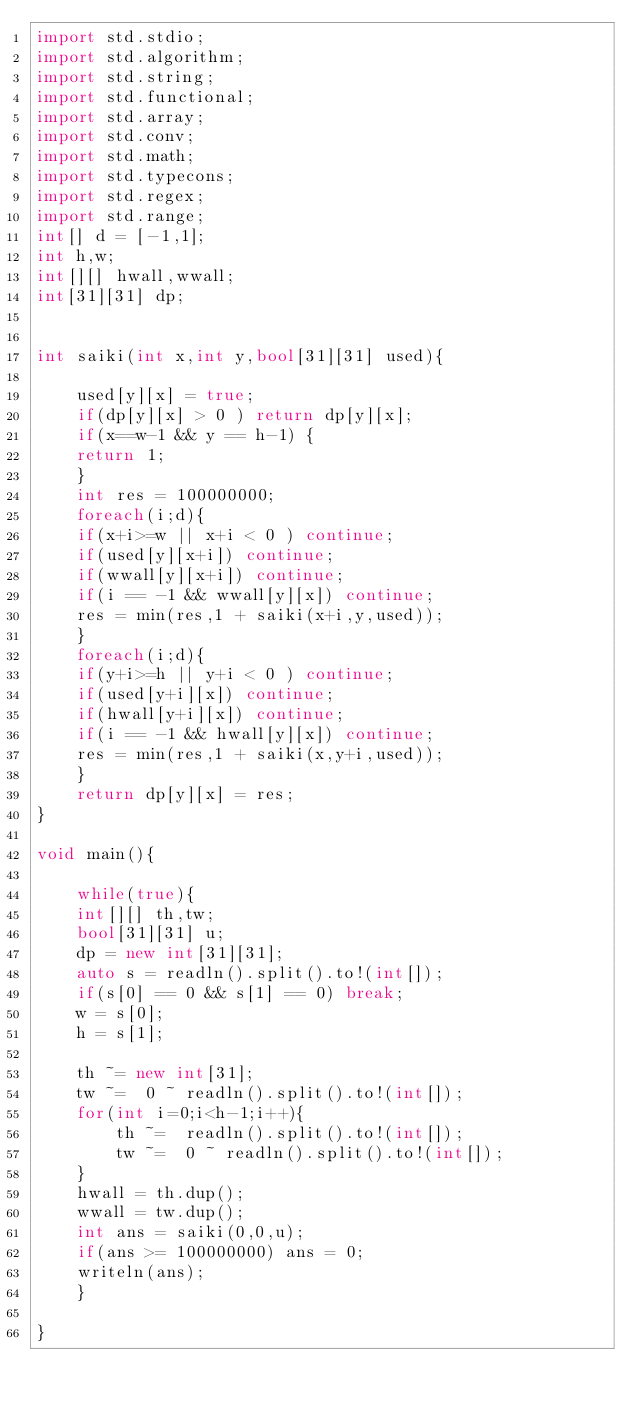Convert code to text. <code><loc_0><loc_0><loc_500><loc_500><_D_>import std.stdio;
import std.algorithm;
import std.string;
import std.functional;
import std.array;
import std.conv;
import std.math;
import std.typecons;
import std.regex;
import std.range;
int[] d = [-1,1];
int h,w;
int[][] hwall,wwall;
int[31][31] dp;


int saiki(int x,int y,bool[31][31] used){

    used[y][x] = true;
    if(dp[y][x] > 0 ) return dp[y][x];
    if(x==w-1 && y == h-1) {
	return 1;
    }
    int res = 100000000;
    foreach(i;d){
	if(x+i>=w || x+i < 0 ) continue;
	if(used[y][x+i]) continue;
	if(wwall[y][x+i]) continue;
	if(i == -1 && wwall[y][x]) continue;
	res = min(res,1 + saiki(x+i,y,used));
    }
    foreach(i;d){
	if(y+i>=h || y+i < 0 ) continue;
	if(used[y+i][x]) continue;
	if(hwall[y+i][x]) continue;
	if(i == -1 && hwall[y][x]) continue;
	res = min(res,1 + saiki(x,y+i,used));
    }
    return dp[y][x] = res;
}

void main(){

    while(true){
	int[][] th,tw;
	bool[31][31] u;
	dp = new int[31][31];
	auto s = readln().split().to!(int[]);
	if(s[0] == 0 && s[1] == 0) break;
	w = s[0];
	h = s[1];

	th ~= new int[31];
	tw ~=  0 ~ readln().split().to!(int[]);
	for(int i=0;i<h-1;i++){
	    th ~=  readln().split().to!(int[]);
	    tw ~=  0 ~ readln().split().to!(int[]);
	}
	hwall = th.dup();
	wwall = tw.dup();
	int ans = saiki(0,0,u);
	if(ans >= 100000000) ans = 0;
	writeln(ans);
    }

}</code> 